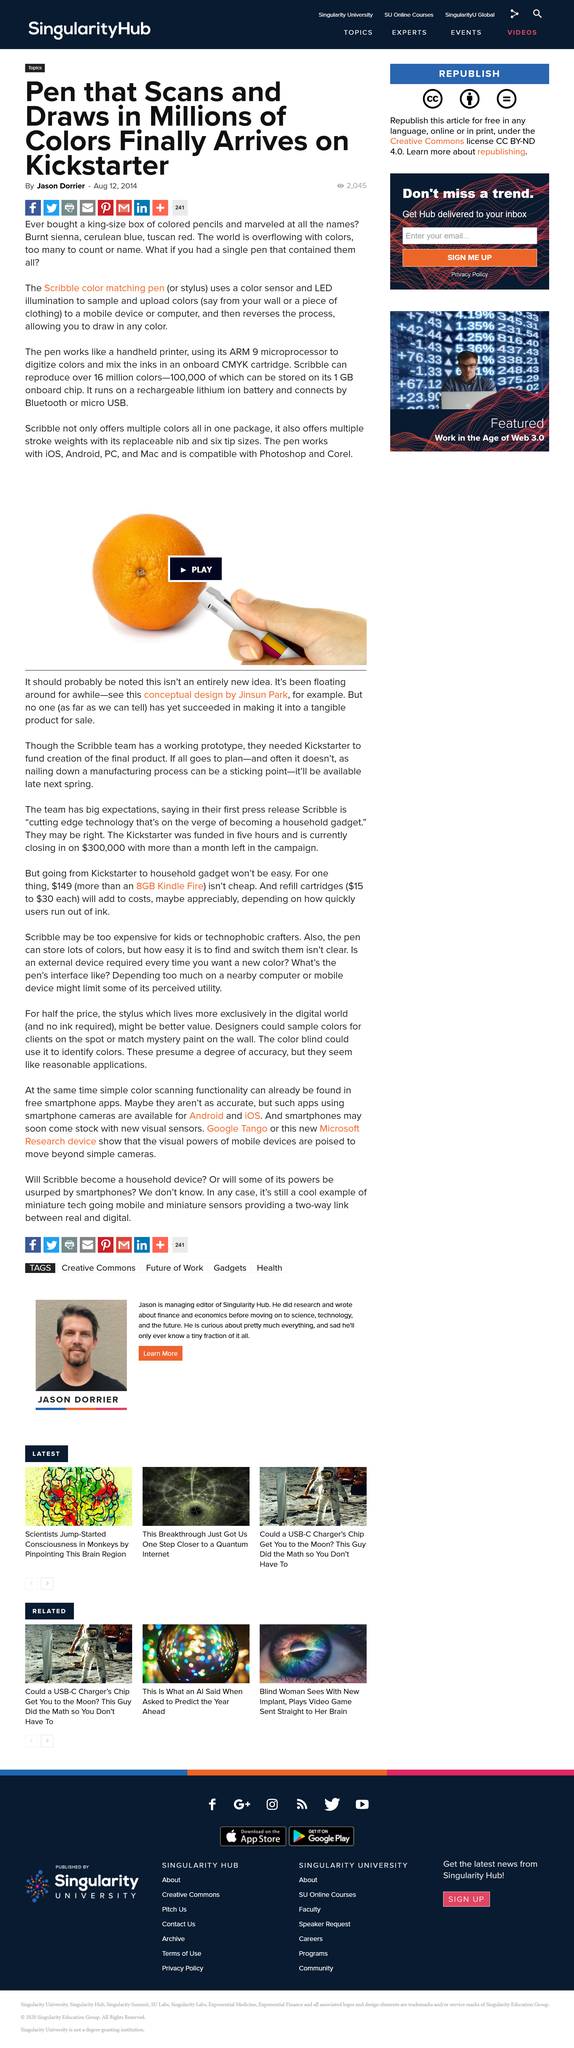Highlight a few significant elements in this photo. The pen uses a rechargeable lithium ion battery. The pen works by using its ARM 9 microprocessor to digitize colors and mix the inks in its onboard CMYK cartridge, similar to how a handheld printer functions. The Scribble pen is capable of reproducing over 16 million colours. 